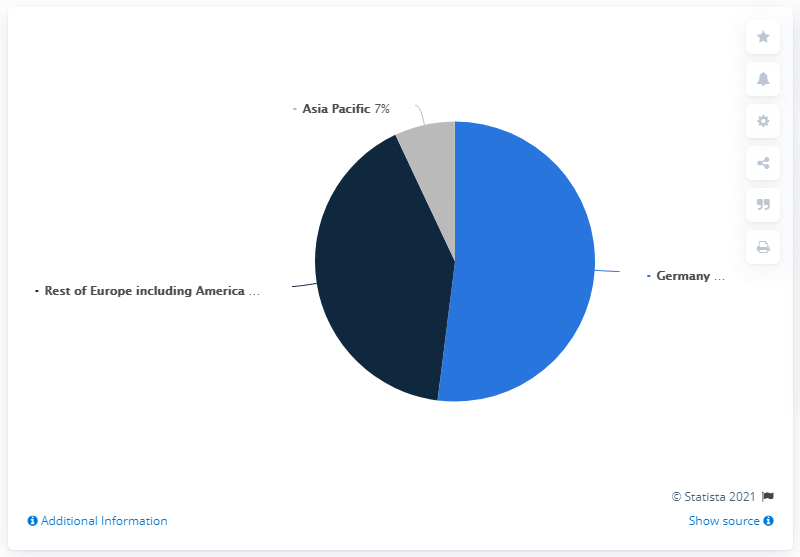Mention a couple of crucial points in this snapshot. The color of the largest pie segment is blue. The revenue generated by the combined Germany and Asia Pacific regions is greater than the revenue generated by the rest of Europe, including America. 